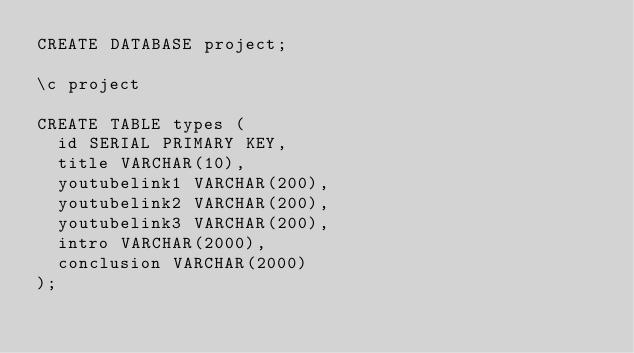<code> <loc_0><loc_0><loc_500><loc_500><_SQL_>CREATE DATABASE project;

\c project

CREATE TABLE types (
	id SERIAL PRIMARY KEY,
	title VARCHAR(10),
	youtubelink1 VARCHAR(200),
	youtubelink2 VARCHAR(200),
	youtubelink3 VARCHAR(200),
	intro VARCHAR(2000),
	conclusion VARCHAR(2000)
);</code> 